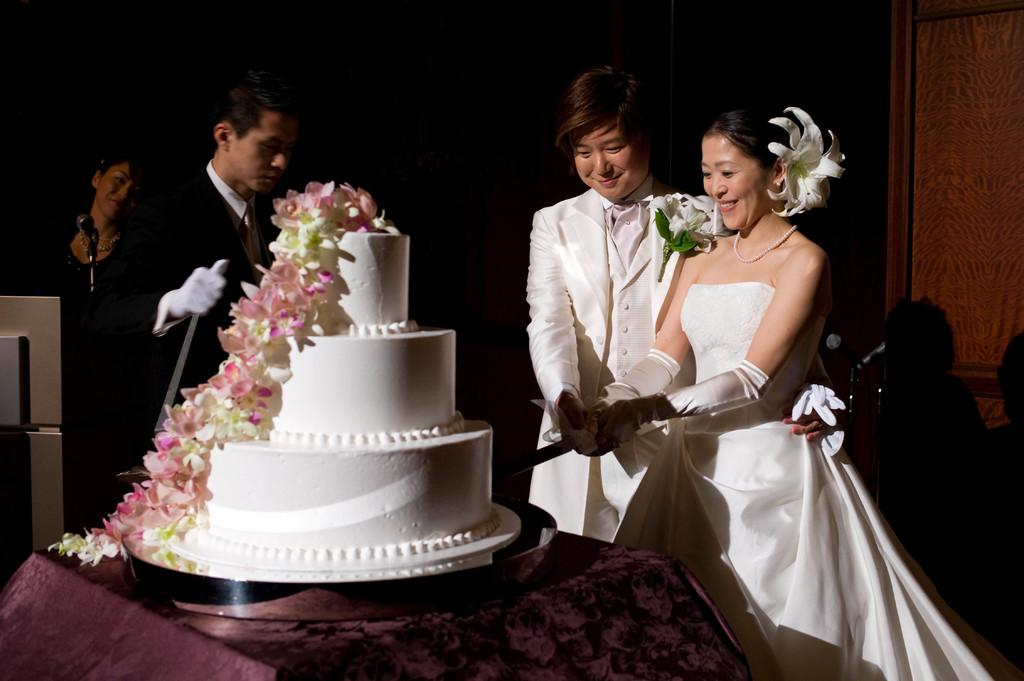How many people are present in the image? There are four persons in the image. What object is used for amplifying sound in the image? There is a microphone (mike) in the image. What sharp object is visible in the image? There is a knife in the image. What food item is on the table in the image? There is a cake on the table in the image. What architectural feature can be seen in the background of the image? There is a door visible in the background of the image. What is the color of the background in the image? The background color appears to be dark. Where might this image have been taken? The image may have been taken in a hall. What type of sponge is being used to clean the floor in the image? There is no sponge visible in the image, and no cleaning activity is taking place. What rate is being discussed by the persons in the image? There is no discussion of rates in the image; the focus appears to be on the objects and setting. 